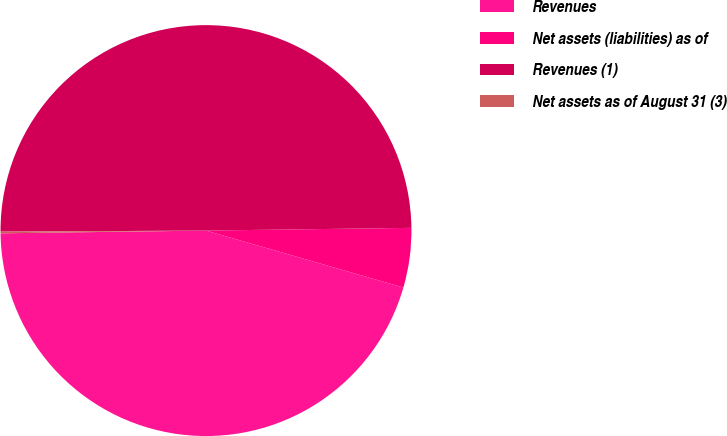<chart> <loc_0><loc_0><loc_500><loc_500><pie_chart><fcel>Revenues<fcel>Net assets (liabilities) as of<fcel>Revenues (1)<fcel>Net assets as of August 31 (3)<nl><fcel>45.32%<fcel>4.68%<fcel>49.87%<fcel>0.13%<nl></chart> 